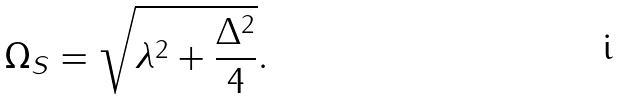<formula> <loc_0><loc_0><loc_500><loc_500>\Omega _ { S } = \sqrt { \lambda ^ { 2 } + \frac { \Delta ^ { 2 } } { 4 } } .</formula> 